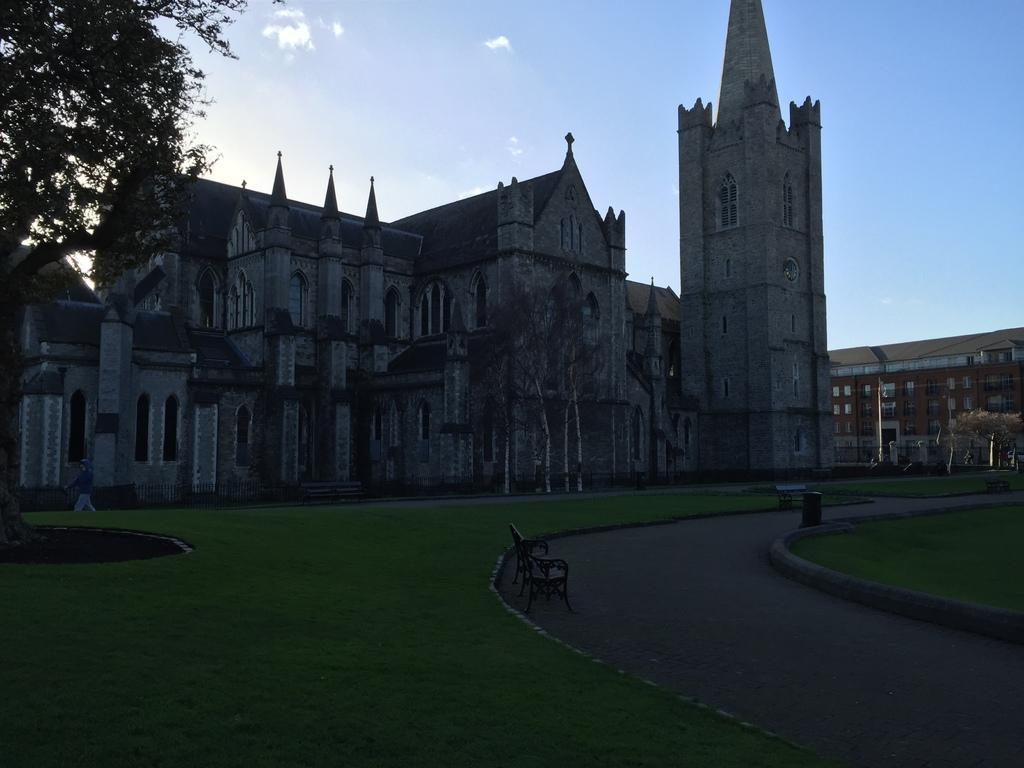Describe this image in one or two sentences. In this image we can see grass on the ground and there is a bench and a dustbin on the road. On the left and right side we can see trees and person is walking at the fence on the left side. In the background there are buildings, windows and clouds in the sky. 